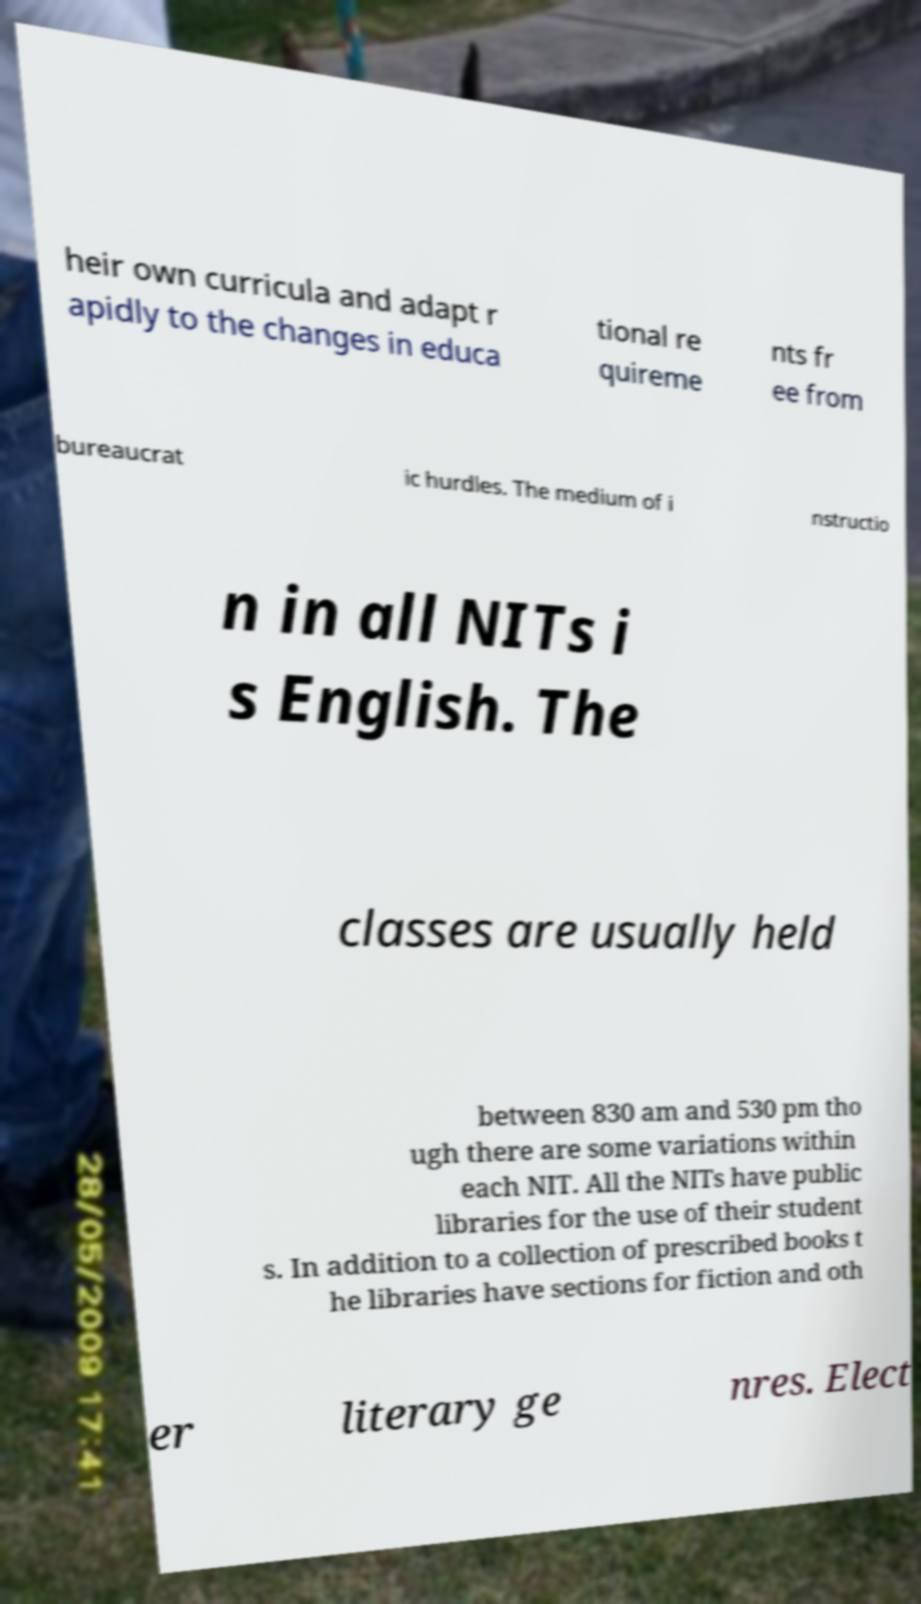Please read and relay the text visible in this image. What does it say? heir own curricula and adapt r apidly to the changes in educa tional re quireme nts fr ee from bureaucrat ic hurdles. The medium of i nstructio n in all NITs i s English. The classes are usually held between 830 am and 530 pm tho ugh there are some variations within each NIT. All the NITs have public libraries for the use of their student s. In addition to a collection of prescribed books t he libraries have sections for fiction and oth er literary ge nres. Elect 